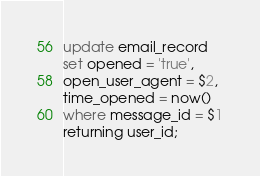<code> <loc_0><loc_0><loc_500><loc_500><_SQL_>update email_record
set opened = 'true',
open_user_agent = $2,
time_opened = now()
where message_id = $1
returning user_id;</code> 